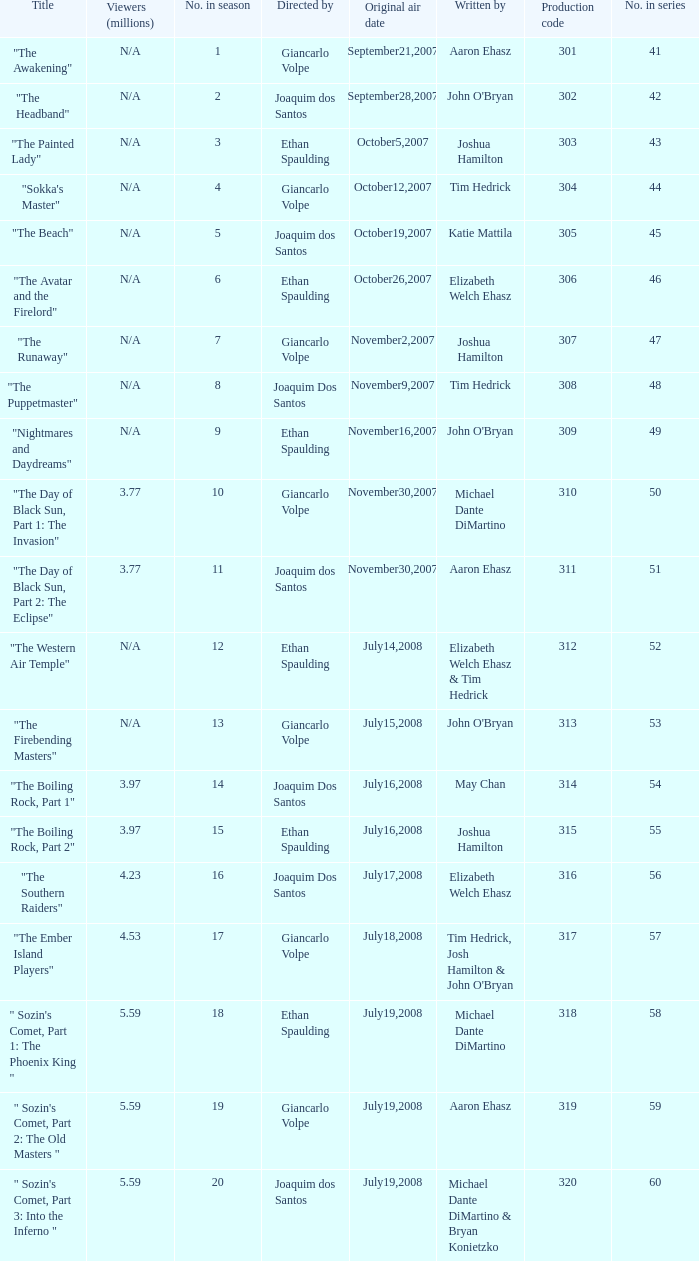What are all the numbers in the series with an episode title of "the beach"? 45.0. 